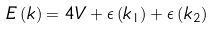<formula> <loc_0><loc_0><loc_500><loc_500>E \left ( { k } \right ) = 4 V + \epsilon \left ( { k } _ { 1 } \right ) + \epsilon \left ( { k } _ { 2 } \right )</formula> 